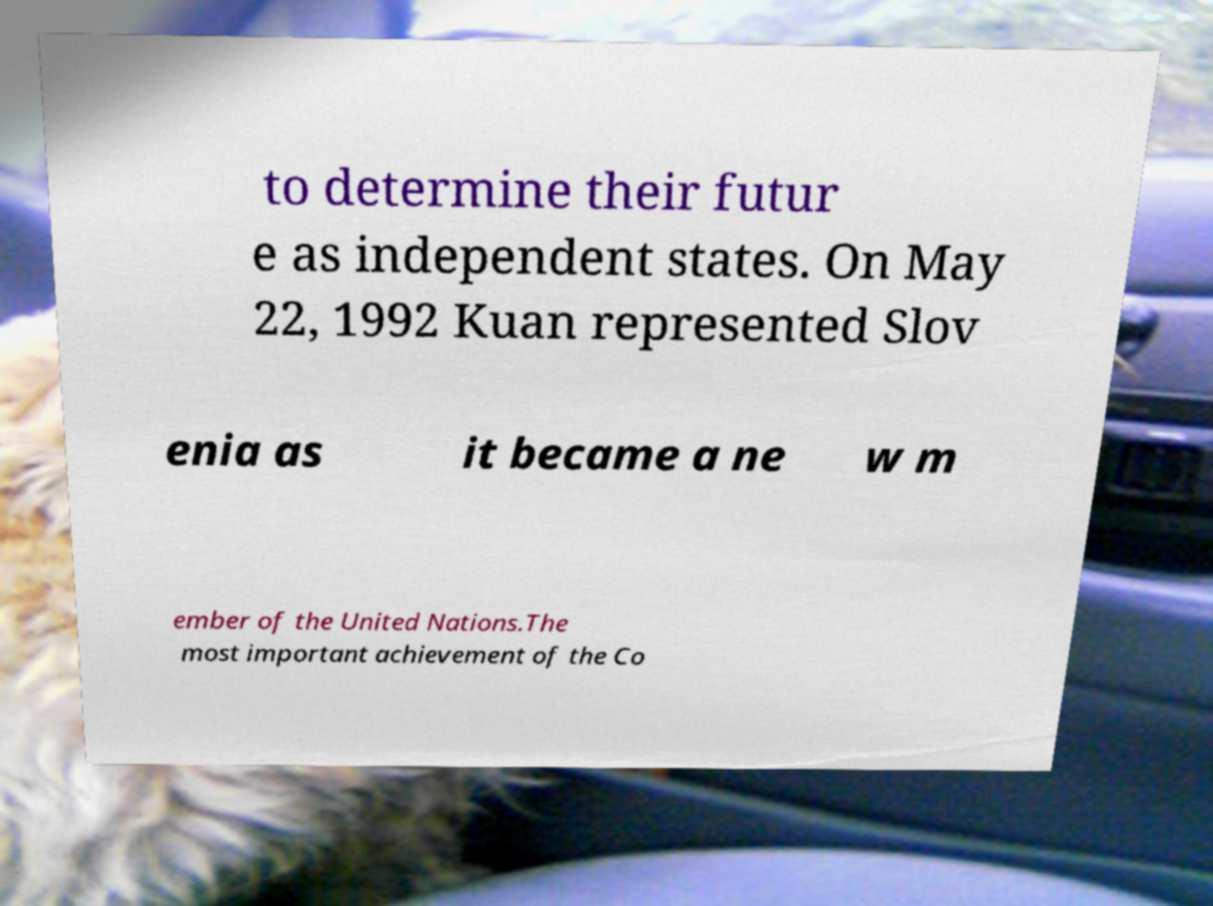Can you accurately transcribe the text from the provided image for me? to determine their futur e as independent states. On May 22, 1992 Kuan represented Slov enia as it became a ne w m ember of the United Nations.The most important achievement of the Co 